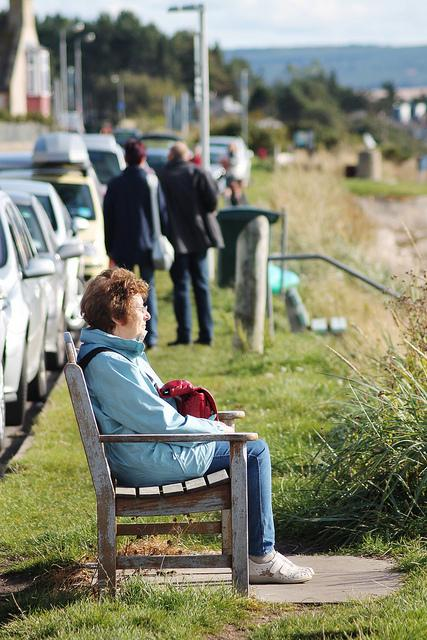How are her shoes tightened? velcro 